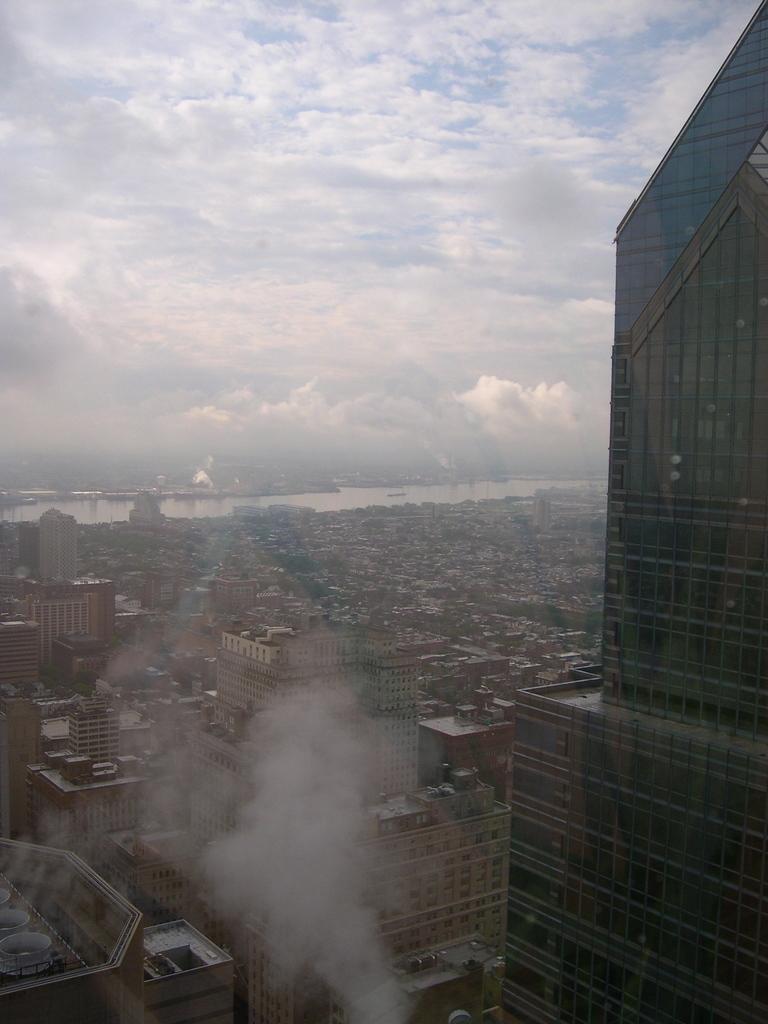In one or two sentences, can you explain what this image depicts? In this image we can see smoke in the middle and there are buildings, glass doors and objects on the building. In the background there are buildings, trees, water and clouds in the sky. 